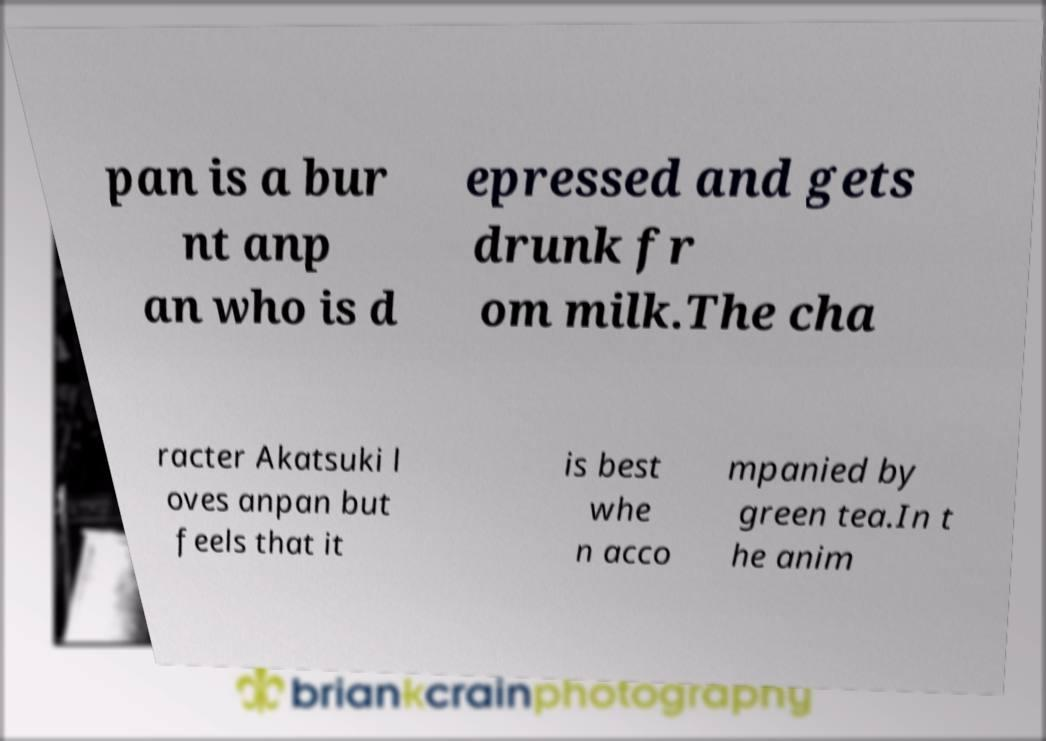Can you accurately transcribe the text from the provided image for me? pan is a bur nt anp an who is d epressed and gets drunk fr om milk.The cha racter Akatsuki l oves anpan but feels that it is best whe n acco mpanied by green tea.In t he anim 